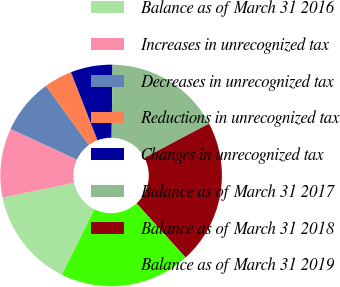Convert chart to OTSL. <chart><loc_0><loc_0><loc_500><loc_500><pie_chart><fcel>Balance as of March 31 2016<fcel>Increases in unrecognized tax<fcel>Decreases in unrecognized tax<fcel>Reductions in unrecognized tax<fcel>Changes in unrecognized tax<fcel>Balance as of March 31 2017<fcel>Balance as of March 31 2018<fcel>Balance as of March 31 2019<nl><fcel>14.51%<fcel>10.08%<fcel>8.09%<fcel>4.11%<fcel>6.1%<fcel>17.05%<fcel>21.03%<fcel>19.04%<nl></chart> 